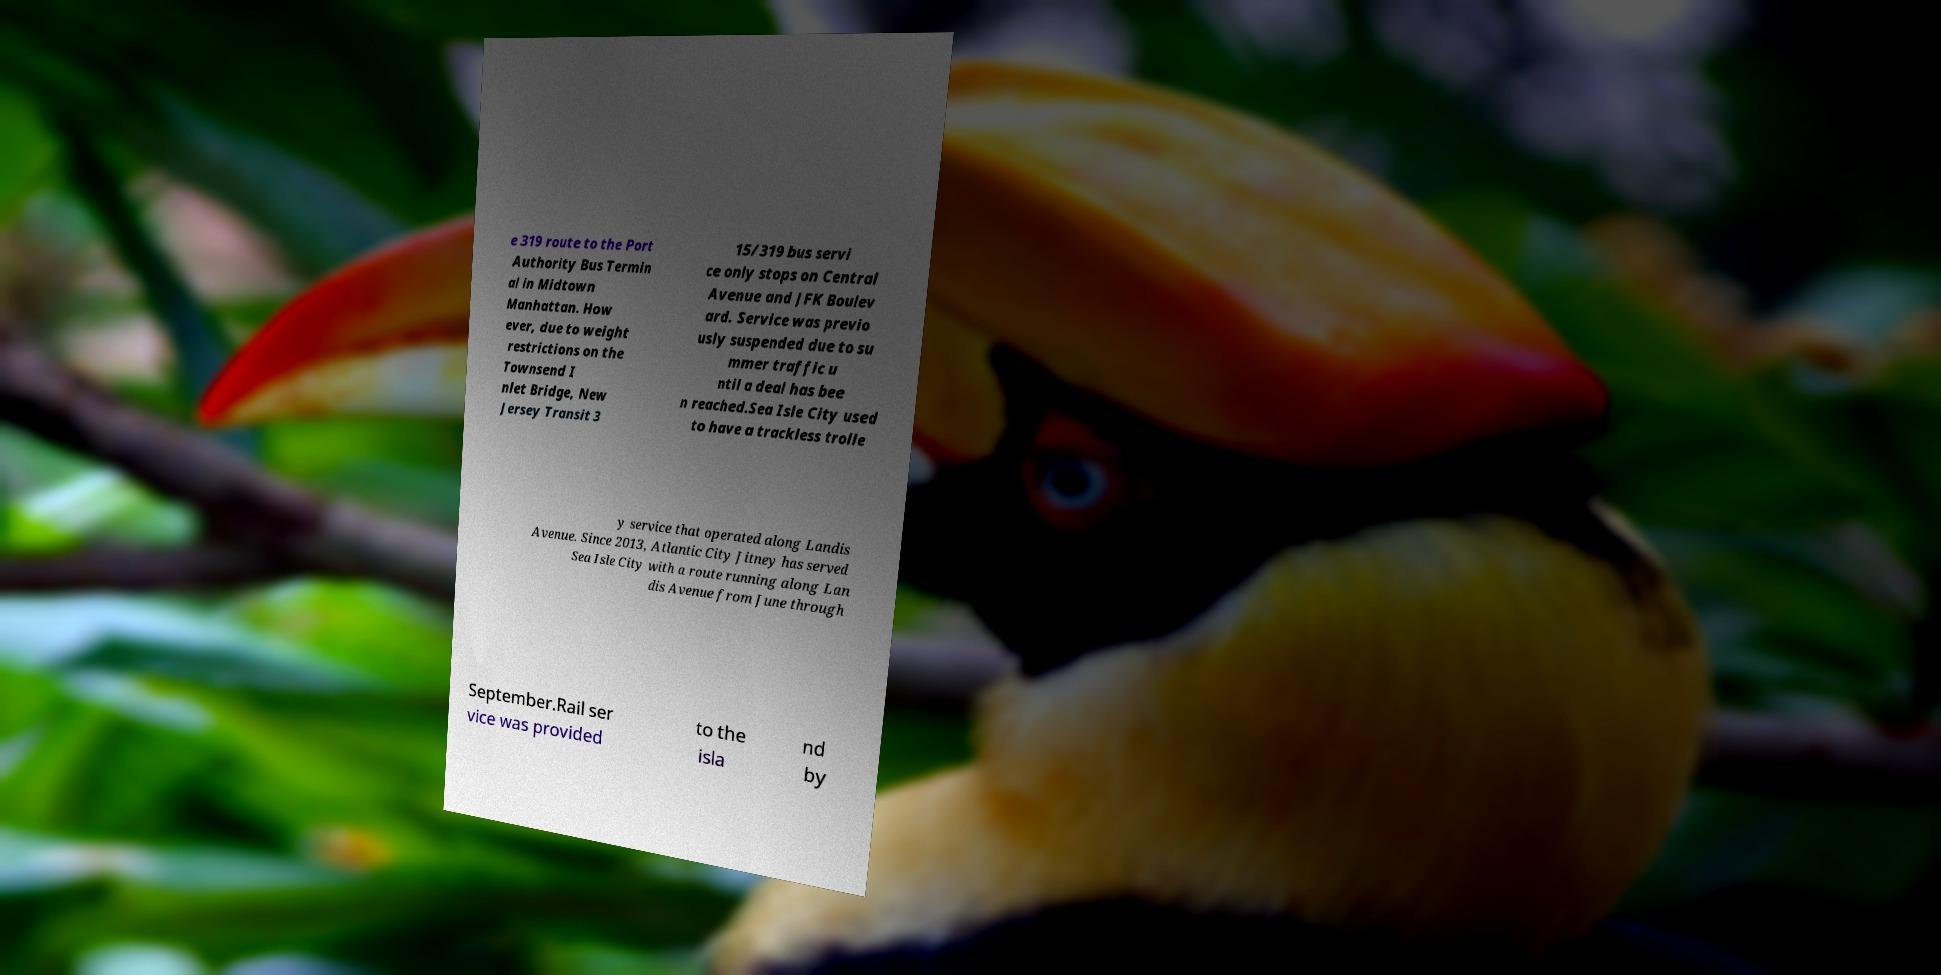Please read and relay the text visible in this image. What does it say? e 319 route to the Port Authority Bus Termin al in Midtown Manhattan. How ever, due to weight restrictions on the Townsend I nlet Bridge, New Jersey Transit 3 15/319 bus servi ce only stops on Central Avenue and JFK Boulev ard. Service was previo usly suspended due to su mmer traffic u ntil a deal has bee n reached.Sea Isle City used to have a trackless trolle y service that operated along Landis Avenue. Since 2013, Atlantic City Jitney has served Sea Isle City with a route running along Lan dis Avenue from June through September.Rail ser vice was provided to the isla nd by 